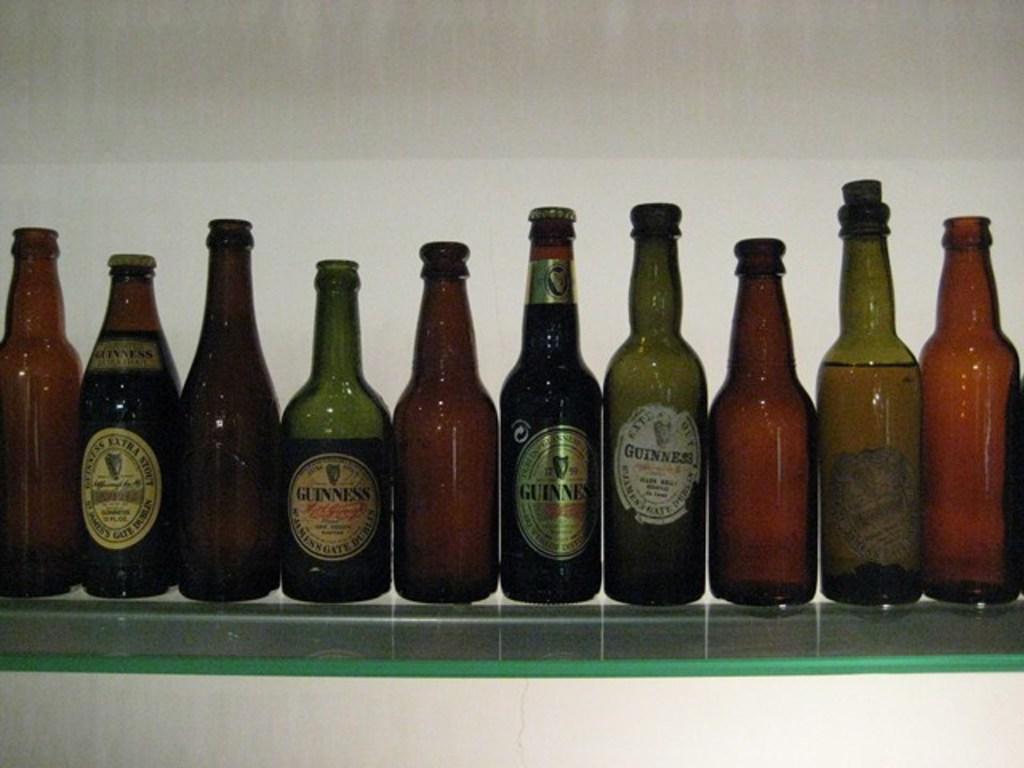Can you describe this image briefly? Here we can see a wine bottles which are arranged in a sequence on this glass table. 